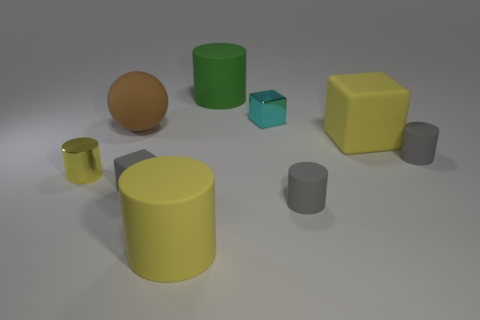Add 1 red rubber cylinders. How many objects exist? 10 Subtract all spheres. How many objects are left? 8 Subtract all tiny brown rubber balls. Subtract all green matte cylinders. How many objects are left? 8 Add 7 large matte spheres. How many large matte spheres are left? 8 Add 5 yellow rubber things. How many yellow rubber things exist? 7 Subtract 0 red cylinders. How many objects are left? 9 